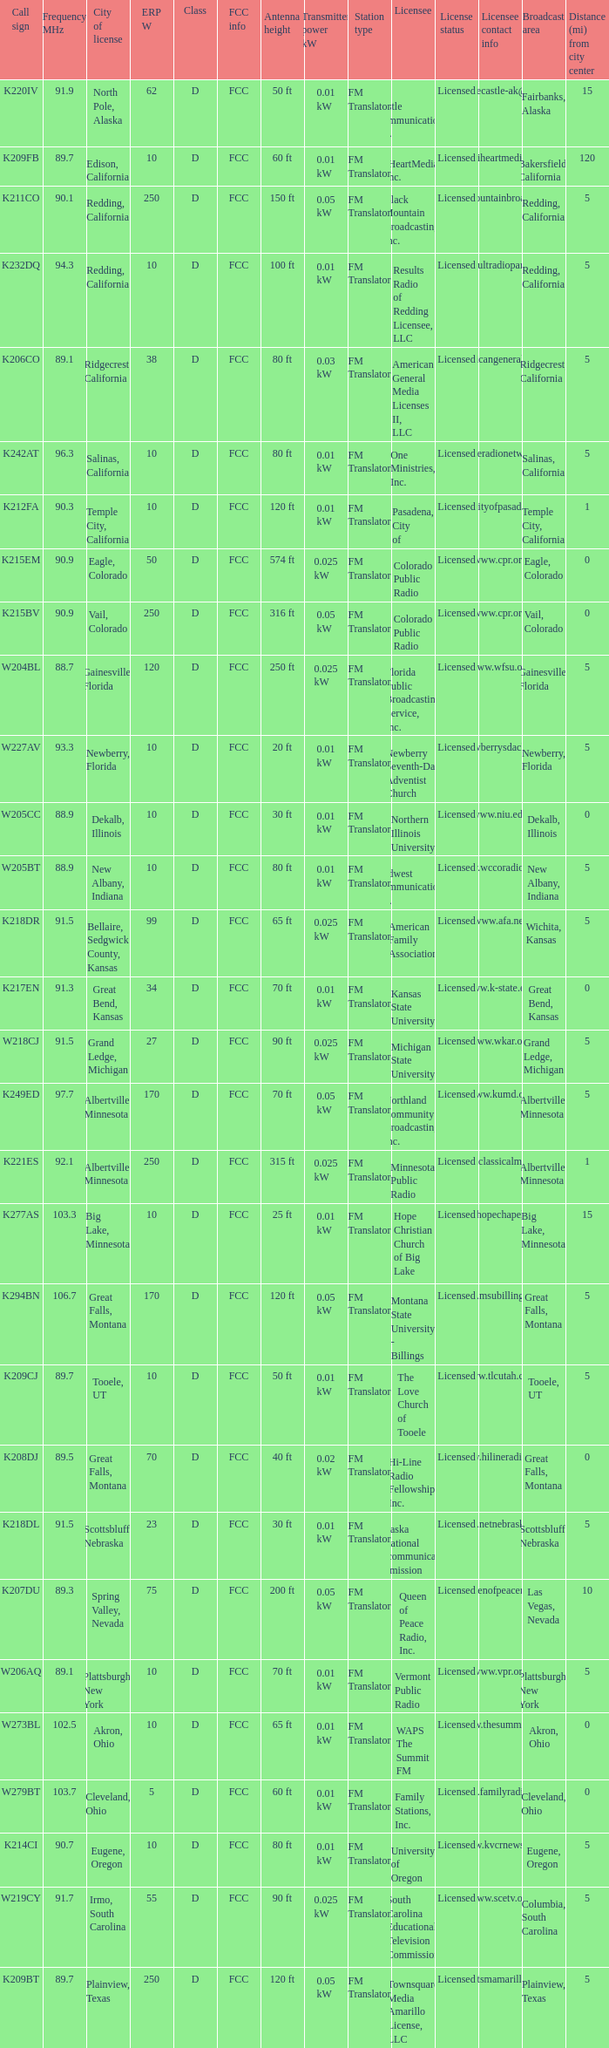What is the call sign of the translator with an ERP W greater than 38 and a city license from Great Falls, Montana? K294BN, K208DJ. 